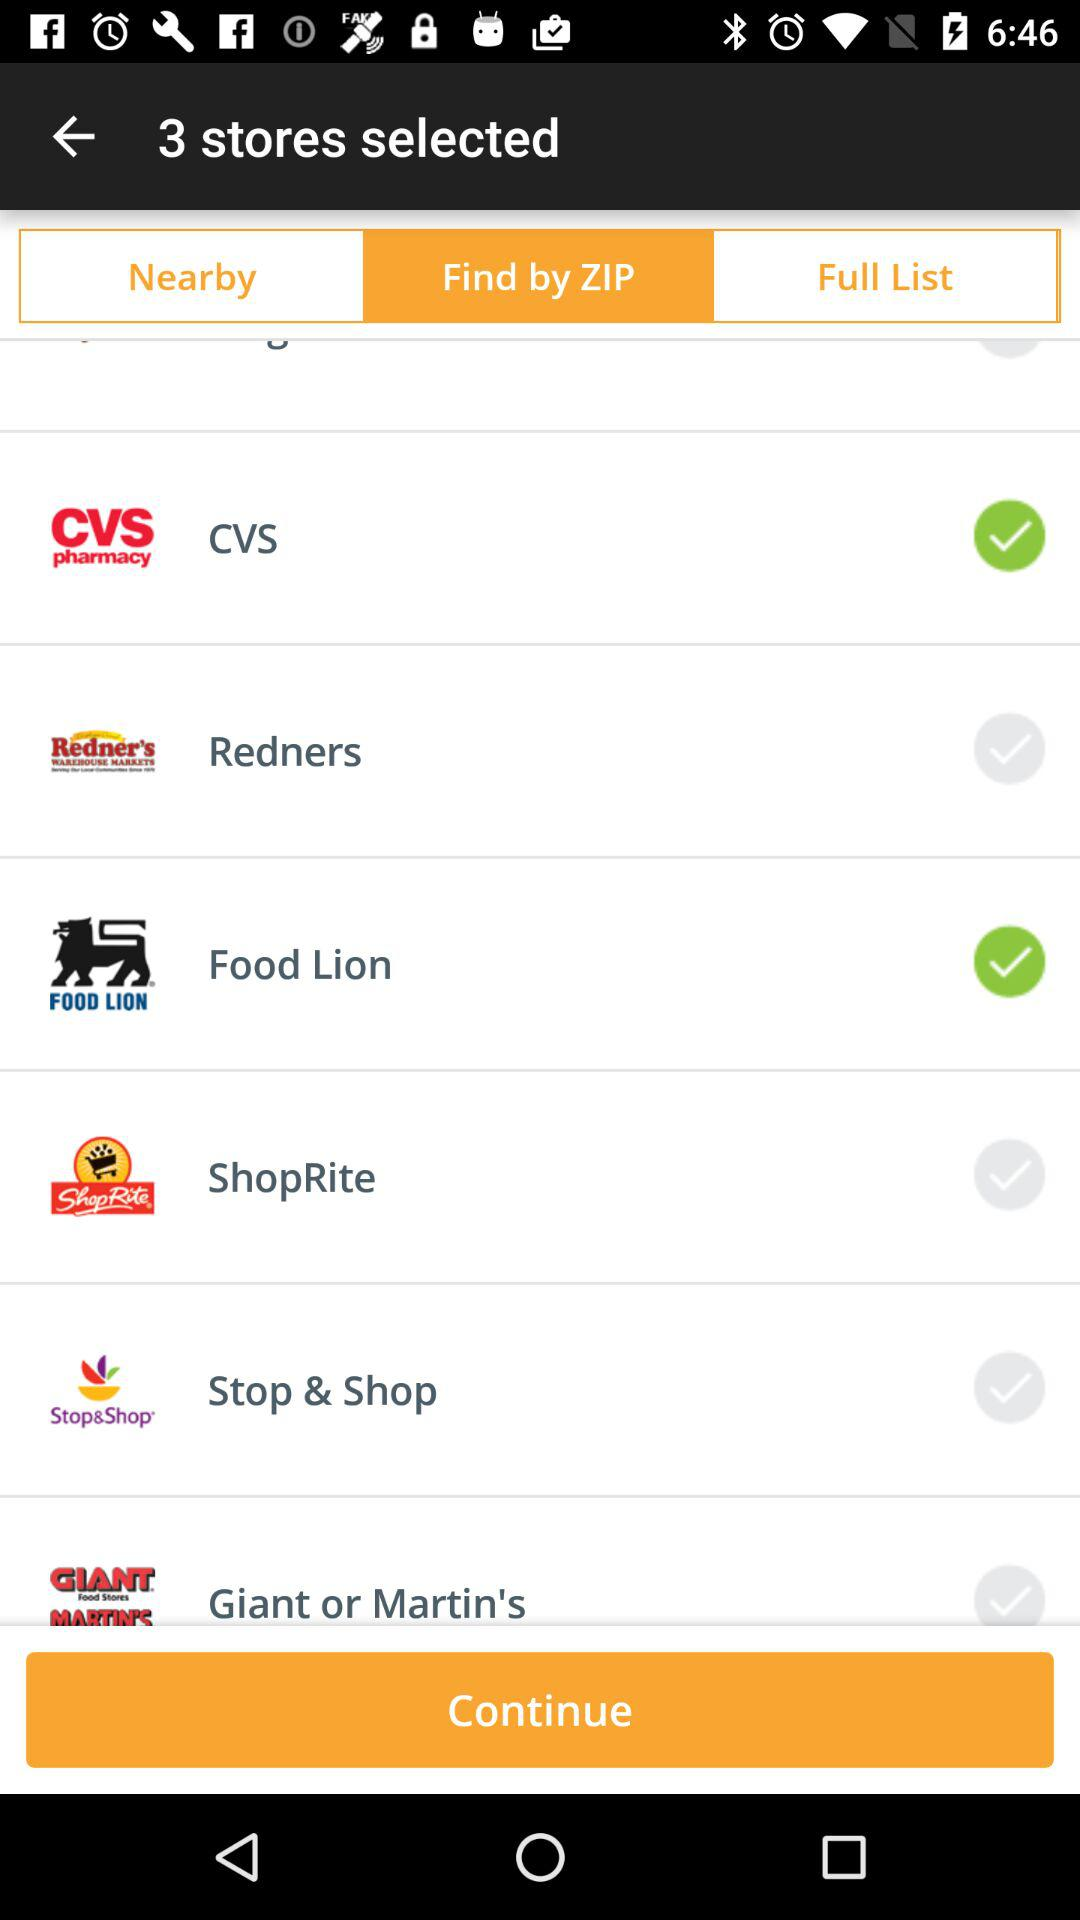Which stores are selected under the "Find by ZIP" category? The selected stores are "CVS" and "Food Lion". 